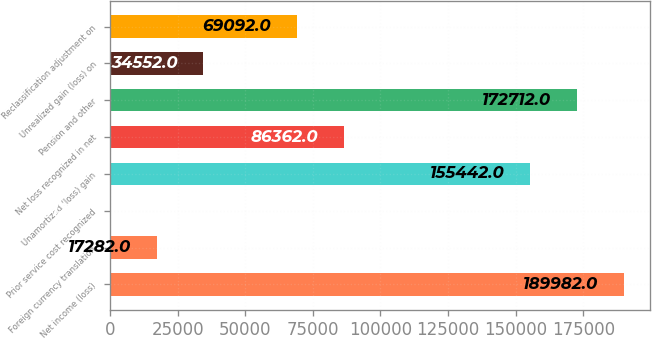Convert chart. <chart><loc_0><loc_0><loc_500><loc_500><bar_chart><fcel>Net income (loss)<fcel>Foreign currency translation<fcel>Prior service cost recognized<fcel>Unamortized (loss) gain<fcel>Net loss recognized in net<fcel>Pension and other<fcel>Unrealized gain (loss) on<fcel>Reclassification adjustment on<nl><fcel>189982<fcel>17282<fcel>12<fcel>155442<fcel>86362<fcel>172712<fcel>34552<fcel>69092<nl></chart> 